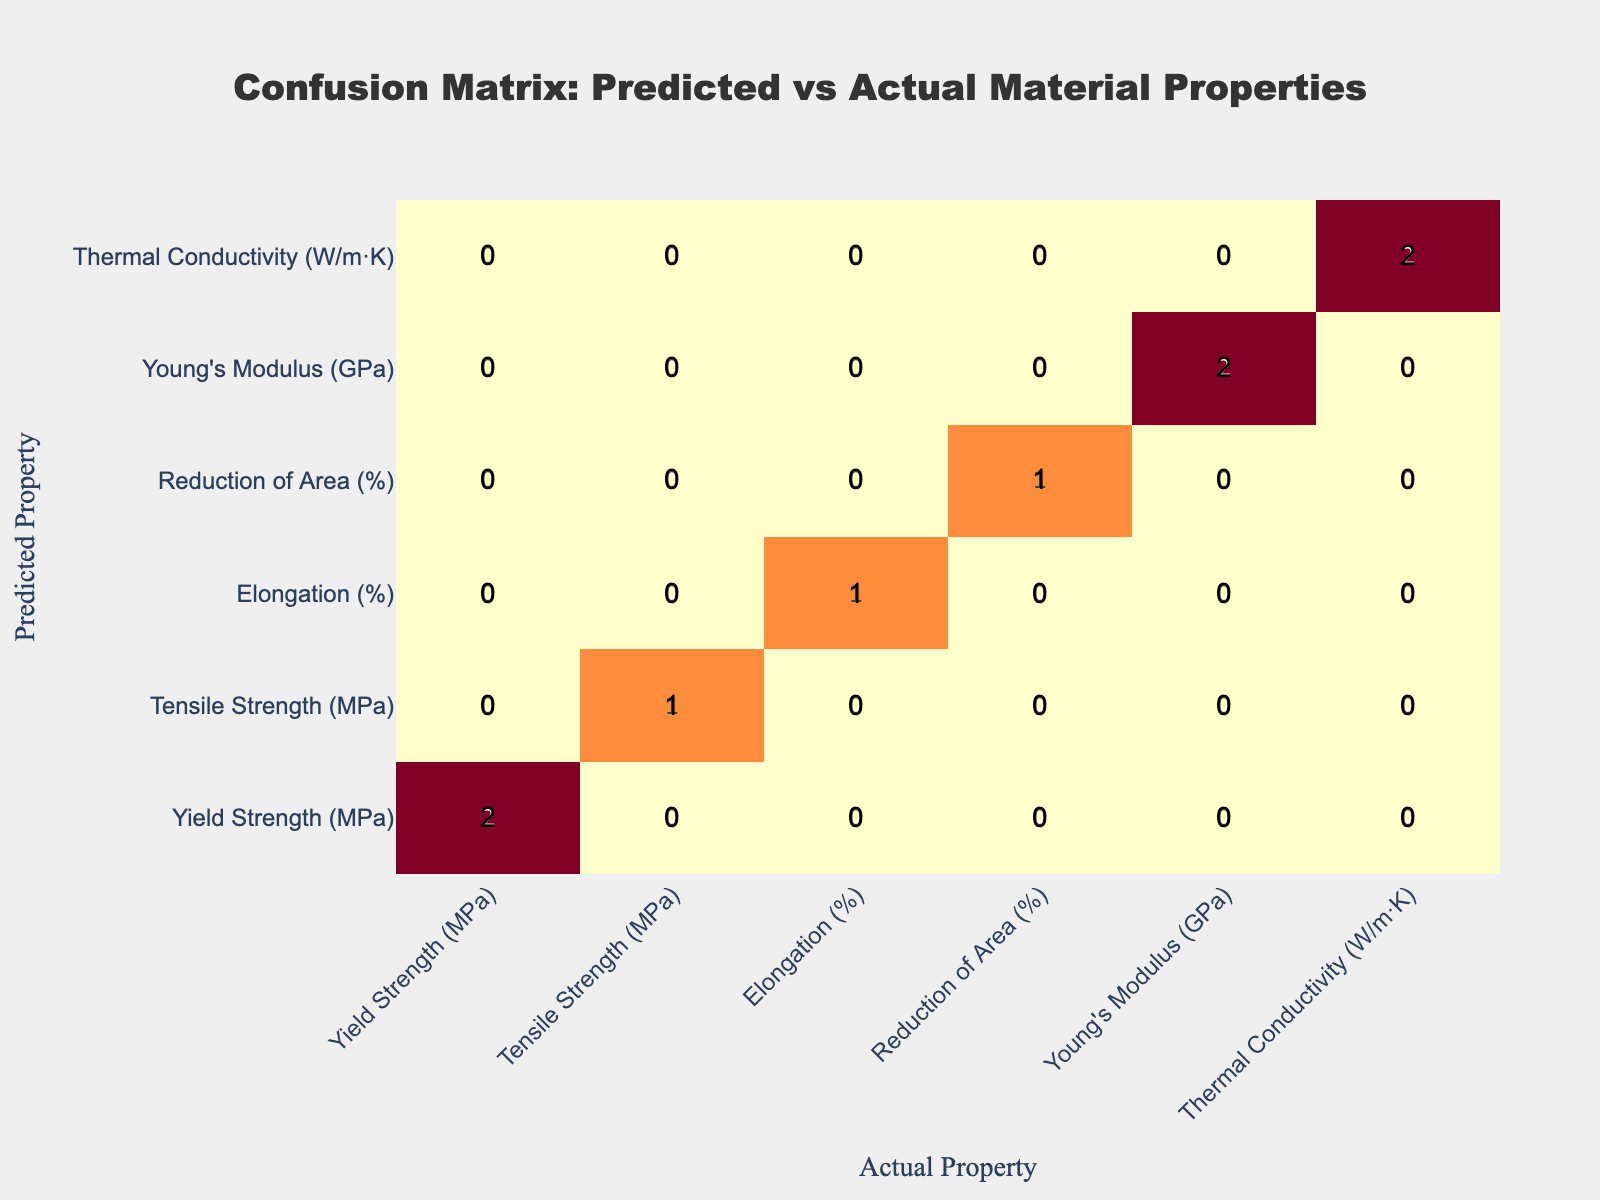What is the predicted property at 400°C? The table indicates that the predicted property at 400°C is Yield Strength (MPa)
Answer: Yield Strength (MPa) How many different actual properties are shown for 500°C? The table shows two predicted properties for 500°C: Yield Strength (MPa) and Elongation (%). Therefore, the actual properties presented are just Elongation (%) and Yield Strength (MPa). Thus, there are two different actual properties
Answer: 2 Is the predicted tensile strength the same as the actual tensile strength at 600°C? The table indicates that for 600°C, the predicted property is Tensile Strength (MPa), and the actual property is also Tensile Strength (MPa). Since both the predicted and actual properties match, the statement is true
Answer: Yes What is the reduction in area percentage for the predicted and actual properties at 600°C? The table shows that for 600°C, the predicted property is Reduction of Area (%) and the actual property is also Reduction of Area (%). Therefore, both predicted and actual properties are the same, which indicates a match of properties at 600°C
Answer: Reduction of Area (%) Which predicted property has no match at 500°C? The table shows Yield Strength (MPa) and Elongation (%) as predicted properties at 500°C. However, neither of these properties indicate any mismatch at this temperature. Therefore, there is no specific property listed that has no match at this temperature
Answer: None 